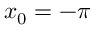Convert formula to latex. <formula><loc_0><loc_0><loc_500><loc_500>x _ { 0 } = - \pi</formula> 